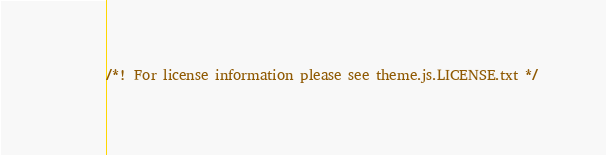<code> <loc_0><loc_0><loc_500><loc_500><_JavaScript_>/*! For license information please see theme.js.LICENSE.txt */</code> 